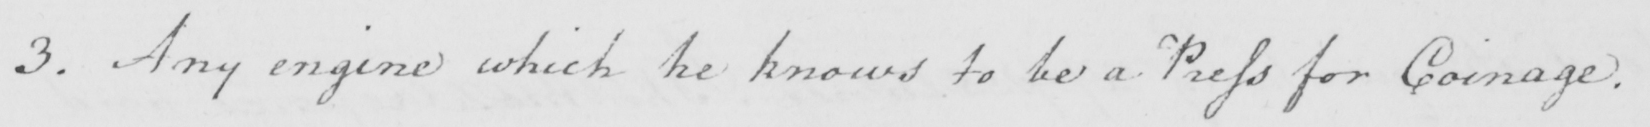Please transcribe the handwritten text in this image. 3 . Any engine which he knows to be a Press for Coinage . 